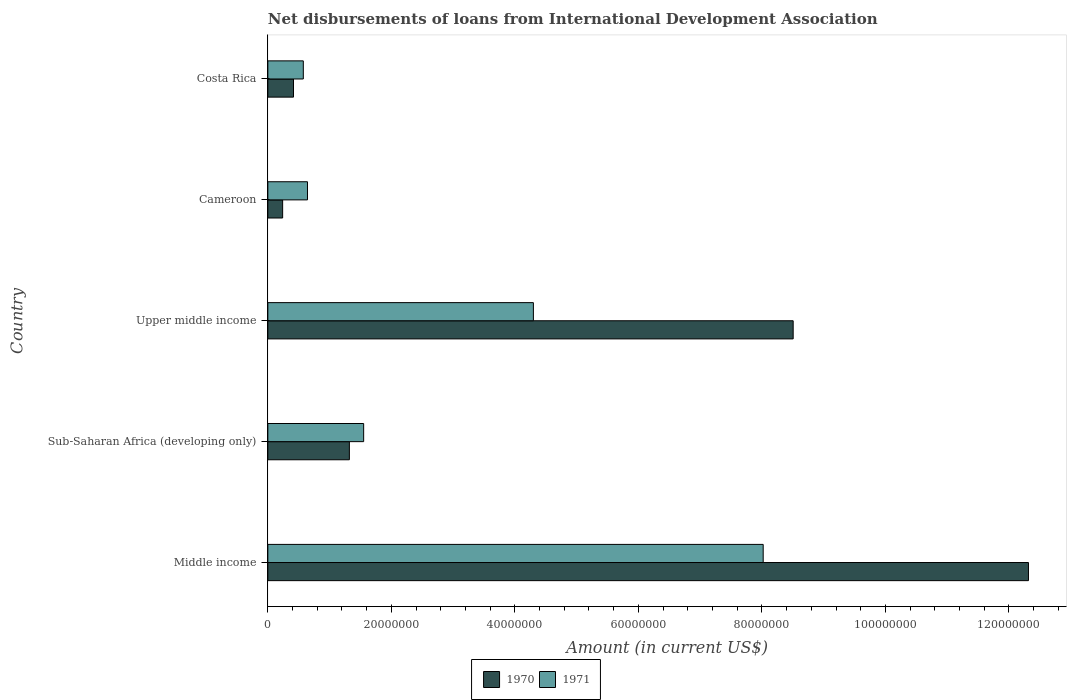Are the number of bars on each tick of the Y-axis equal?
Offer a terse response. Yes. How many bars are there on the 5th tick from the top?
Your response must be concise. 2. What is the label of the 3rd group of bars from the top?
Offer a terse response. Upper middle income. In how many cases, is the number of bars for a given country not equal to the number of legend labels?
Provide a short and direct response. 0. What is the amount of loans disbursed in 1970 in Costa Rica?
Provide a short and direct response. 4.15e+06. Across all countries, what is the maximum amount of loans disbursed in 1971?
Your answer should be very brief. 8.02e+07. Across all countries, what is the minimum amount of loans disbursed in 1971?
Give a very brief answer. 5.74e+06. In which country was the amount of loans disbursed in 1970 minimum?
Keep it short and to the point. Cameroon. What is the total amount of loans disbursed in 1970 in the graph?
Provide a succinct answer. 2.28e+08. What is the difference between the amount of loans disbursed in 1971 in Sub-Saharan Africa (developing only) and that in Upper middle income?
Your answer should be very brief. -2.75e+07. What is the difference between the amount of loans disbursed in 1970 in Costa Rica and the amount of loans disbursed in 1971 in Middle income?
Your answer should be very brief. -7.61e+07. What is the average amount of loans disbursed in 1971 per country?
Your answer should be compact. 3.02e+07. What is the difference between the amount of loans disbursed in 1970 and amount of loans disbursed in 1971 in Cameroon?
Your answer should be compact. -4.02e+06. In how many countries, is the amount of loans disbursed in 1971 greater than 32000000 US$?
Offer a very short reply. 2. What is the ratio of the amount of loans disbursed in 1971 in Sub-Saharan Africa (developing only) to that in Upper middle income?
Ensure brevity in your answer.  0.36. What is the difference between the highest and the second highest amount of loans disbursed in 1971?
Offer a very short reply. 3.72e+07. What is the difference between the highest and the lowest amount of loans disbursed in 1971?
Your response must be concise. 7.45e+07. In how many countries, is the amount of loans disbursed in 1971 greater than the average amount of loans disbursed in 1971 taken over all countries?
Offer a very short reply. 2. Is the sum of the amount of loans disbursed in 1970 in Costa Rica and Middle income greater than the maximum amount of loans disbursed in 1971 across all countries?
Provide a short and direct response. Yes. How many bars are there?
Offer a very short reply. 10. How many countries are there in the graph?
Your answer should be very brief. 5. Are the values on the major ticks of X-axis written in scientific E-notation?
Provide a short and direct response. No. Does the graph contain any zero values?
Give a very brief answer. No. Does the graph contain grids?
Provide a short and direct response. No. Where does the legend appear in the graph?
Offer a terse response. Bottom center. How many legend labels are there?
Make the answer very short. 2. How are the legend labels stacked?
Make the answer very short. Horizontal. What is the title of the graph?
Make the answer very short. Net disbursements of loans from International Development Association. What is the label or title of the Y-axis?
Give a very brief answer. Country. What is the Amount (in current US$) in 1970 in Middle income?
Provide a succinct answer. 1.23e+08. What is the Amount (in current US$) of 1971 in Middle income?
Your answer should be very brief. 8.02e+07. What is the Amount (in current US$) in 1970 in Sub-Saharan Africa (developing only)?
Your response must be concise. 1.32e+07. What is the Amount (in current US$) in 1971 in Sub-Saharan Africa (developing only)?
Provide a succinct answer. 1.55e+07. What is the Amount (in current US$) in 1970 in Upper middle income?
Keep it short and to the point. 8.51e+07. What is the Amount (in current US$) of 1971 in Upper middle income?
Your response must be concise. 4.30e+07. What is the Amount (in current US$) of 1970 in Cameroon?
Provide a short and direct response. 2.40e+06. What is the Amount (in current US$) in 1971 in Cameroon?
Offer a very short reply. 6.42e+06. What is the Amount (in current US$) of 1970 in Costa Rica?
Keep it short and to the point. 4.15e+06. What is the Amount (in current US$) of 1971 in Costa Rica?
Give a very brief answer. 5.74e+06. Across all countries, what is the maximum Amount (in current US$) in 1970?
Offer a terse response. 1.23e+08. Across all countries, what is the maximum Amount (in current US$) of 1971?
Offer a very short reply. 8.02e+07. Across all countries, what is the minimum Amount (in current US$) in 1970?
Your response must be concise. 2.40e+06. Across all countries, what is the minimum Amount (in current US$) of 1971?
Your response must be concise. 5.74e+06. What is the total Amount (in current US$) in 1970 in the graph?
Offer a very short reply. 2.28e+08. What is the total Amount (in current US$) in 1971 in the graph?
Your answer should be very brief. 1.51e+08. What is the difference between the Amount (in current US$) in 1970 in Middle income and that in Sub-Saharan Africa (developing only)?
Provide a succinct answer. 1.10e+08. What is the difference between the Amount (in current US$) of 1971 in Middle income and that in Sub-Saharan Africa (developing only)?
Your response must be concise. 6.47e+07. What is the difference between the Amount (in current US$) in 1970 in Middle income and that in Upper middle income?
Your answer should be compact. 3.81e+07. What is the difference between the Amount (in current US$) in 1971 in Middle income and that in Upper middle income?
Provide a short and direct response. 3.72e+07. What is the difference between the Amount (in current US$) of 1970 in Middle income and that in Cameroon?
Ensure brevity in your answer.  1.21e+08. What is the difference between the Amount (in current US$) in 1971 in Middle income and that in Cameroon?
Offer a terse response. 7.38e+07. What is the difference between the Amount (in current US$) in 1970 in Middle income and that in Costa Rica?
Provide a succinct answer. 1.19e+08. What is the difference between the Amount (in current US$) of 1971 in Middle income and that in Costa Rica?
Offer a terse response. 7.45e+07. What is the difference between the Amount (in current US$) in 1970 in Sub-Saharan Africa (developing only) and that in Upper middle income?
Offer a very short reply. -7.19e+07. What is the difference between the Amount (in current US$) of 1971 in Sub-Saharan Africa (developing only) and that in Upper middle income?
Your answer should be compact. -2.75e+07. What is the difference between the Amount (in current US$) in 1970 in Sub-Saharan Africa (developing only) and that in Cameroon?
Ensure brevity in your answer.  1.08e+07. What is the difference between the Amount (in current US$) in 1971 in Sub-Saharan Africa (developing only) and that in Cameroon?
Keep it short and to the point. 9.10e+06. What is the difference between the Amount (in current US$) in 1970 in Sub-Saharan Africa (developing only) and that in Costa Rica?
Your response must be concise. 9.05e+06. What is the difference between the Amount (in current US$) in 1971 in Sub-Saharan Africa (developing only) and that in Costa Rica?
Your response must be concise. 9.77e+06. What is the difference between the Amount (in current US$) of 1970 in Upper middle income and that in Cameroon?
Your answer should be very brief. 8.27e+07. What is the difference between the Amount (in current US$) of 1971 in Upper middle income and that in Cameroon?
Your response must be concise. 3.66e+07. What is the difference between the Amount (in current US$) of 1970 in Upper middle income and that in Costa Rica?
Provide a succinct answer. 8.09e+07. What is the difference between the Amount (in current US$) in 1971 in Upper middle income and that in Costa Rica?
Your response must be concise. 3.73e+07. What is the difference between the Amount (in current US$) in 1970 in Cameroon and that in Costa Rica?
Ensure brevity in your answer.  -1.76e+06. What is the difference between the Amount (in current US$) in 1971 in Cameroon and that in Costa Rica?
Offer a very short reply. 6.75e+05. What is the difference between the Amount (in current US$) in 1970 in Middle income and the Amount (in current US$) in 1971 in Sub-Saharan Africa (developing only)?
Give a very brief answer. 1.08e+08. What is the difference between the Amount (in current US$) of 1970 in Middle income and the Amount (in current US$) of 1971 in Upper middle income?
Your answer should be compact. 8.02e+07. What is the difference between the Amount (in current US$) in 1970 in Middle income and the Amount (in current US$) in 1971 in Cameroon?
Your answer should be compact. 1.17e+08. What is the difference between the Amount (in current US$) in 1970 in Middle income and the Amount (in current US$) in 1971 in Costa Rica?
Provide a short and direct response. 1.17e+08. What is the difference between the Amount (in current US$) of 1970 in Sub-Saharan Africa (developing only) and the Amount (in current US$) of 1971 in Upper middle income?
Your answer should be very brief. -2.98e+07. What is the difference between the Amount (in current US$) of 1970 in Sub-Saharan Africa (developing only) and the Amount (in current US$) of 1971 in Cameroon?
Keep it short and to the point. 6.78e+06. What is the difference between the Amount (in current US$) in 1970 in Sub-Saharan Africa (developing only) and the Amount (in current US$) in 1971 in Costa Rica?
Your response must be concise. 7.46e+06. What is the difference between the Amount (in current US$) of 1970 in Upper middle income and the Amount (in current US$) of 1971 in Cameroon?
Your response must be concise. 7.86e+07. What is the difference between the Amount (in current US$) of 1970 in Upper middle income and the Amount (in current US$) of 1971 in Costa Rica?
Provide a short and direct response. 7.93e+07. What is the difference between the Amount (in current US$) of 1970 in Cameroon and the Amount (in current US$) of 1971 in Costa Rica?
Keep it short and to the point. -3.35e+06. What is the average Amount (in current US$) of 1970 per country?
Provide a short and direct response. 4.56e+07. What is the average Amount (in current US$) in 1971 per country?
Make the answer very short. 3.02e+07. What is the difference between the Amount (in current US$) in 1970 and Amount (in current US$) in 1971 in Middle income?
Offer a terse response. 4.30e+07. What is the difference between the Amount (in current US$) in 1970 and Amount (in current US$) in 1971 in Sub-Saharan Africa (developing only)?
Your response must be concise. -2.31e+06. What is the difference between the Amount (in current US$) of 1970 and Amount (in current US$) of 1971 in Upper middle income?
Your answer should be very brief. 4.21e+07. What is the difference between the Amount (in current US$) in 1970 and Amount (in current US$) in 1971 in Cameroon?
Ensure brevity in your answer.  -4.02e+06. What is the difference between the Amount (in current US$) in 1970 and Amount (in current US$) in 1971 in Costa Rica?
Provide a short and direct response. -1.59e+06. What is the ratio of the Amount (in current US$) of 1970 in Middle income to that in Sub-Saharan Africa (developing only)?
Offer a terse response. 9.33. What is the ratio of the Amount (in current US$) in 1971 in Middle income to that in Sub-Saharan Africa (developing only)?
Your answer should be compact. 5.17. What is the ratio of the Amount (in current US$) in 1970 in Middle income to that in Upper middle income?
Offer a very short reply. 1.45. What is the ratio of the Amount (in current US$) in 1971 in Middle income to that in Upper middle income?
Your response must be concise. 1.87. What is the ratio of the Amount (in current US$) of 1970 in Middle income to that in Cameroon?
Make the answer very short. 51.4. What is the ratio of the Amount (in current US$) in 1971 in Middle income to that in Cameroon?
Your response must be concise. 12.5. What is the ratio of the Amount (in current US$) in 1970 in Middle income to that in Costa Rica?
Provide a short and direct response. 29.66. What is the ratio of the Amount (in current US$) in 1971 in Middle income to that in Costa Rica?
Provide a succinct answer. 13.96. What is the ratio of the Amount (in current US$) of 1970 in Sub-Saharan Africa (developing only) to that in Upper middle income?
Make the answer very short. 0.16. What is the ratio of the Amount (in current US$) of 1971 in Sub-Saharan Africa (developing only) to that in Upper middle income?
Ensure brevity in your answer.  0.36. What is the ratio of the Amount (in current US$) of 1970 in Sub-Saharan Africa (developing only) to that in Cameroon?
Your answer should be compact. 5.51. What is the ratio of the Amount (in current US$) in 1971 in Sub-Saharan Africa (developing only) to that in Cameroon?
Offer a terse response. 2.42. What is the ratio of the Amount (in current US$) of 1970 in Sub-Saharan Africa (developing only) to that in Costa Rica?
Keep it short and to the point. 3.18. What is the ratio of the Amount (in current US$) of 1971 in Sub-Saharan Africa (developing only) to that in Costa Rica?
Provide a succinct answer. 2.7. What is the ratio of the Amount (in current US$) in 1970 in Upper middle income to that in Cameroon?
Ensure brevity in your answer.  35.5. What is the ratio of the Amount (in current US$) of 1971 in Upper middle income to that in Cameroon?
Keep it short and to the point. 6.7. What is the ratio of the Amount (in current US$) in 1970 in Upper middle income to that in Costa Rica?
Provide a short and direct response. 20.48. What is the ratio of the Amount (in current US$) in 1971 in Upper middle income to that in Costa Rica?
Provide a short and direct response. 7.49. What is the ratio of the Amount (in current US$) in 1970 in Cameroon to that in Costa Rica?
Make the answer very short. 0.58. What is the ratio of the Amount (in current US$) in 1971 in Cameroon to that in Costa Rica?
Your response must be concise. 1.12. What is the difference between the highest and the second highest Amount (in current US$) in 1970?
Offer a terse response. 3.81e+07. What is the difference between the highest and the second highest Amount (in current US$) of 1971?
Your answer should be compact. 3.72e+07. What is the difference between the highest and the lowest Amount (in current US$) of 1970?
Keep it short and to the point. 1.21e+08. What is the difference between the highest and the lowest Amount (in current US$) in 1971?
Give a very brief answer. 7.45e+07. 